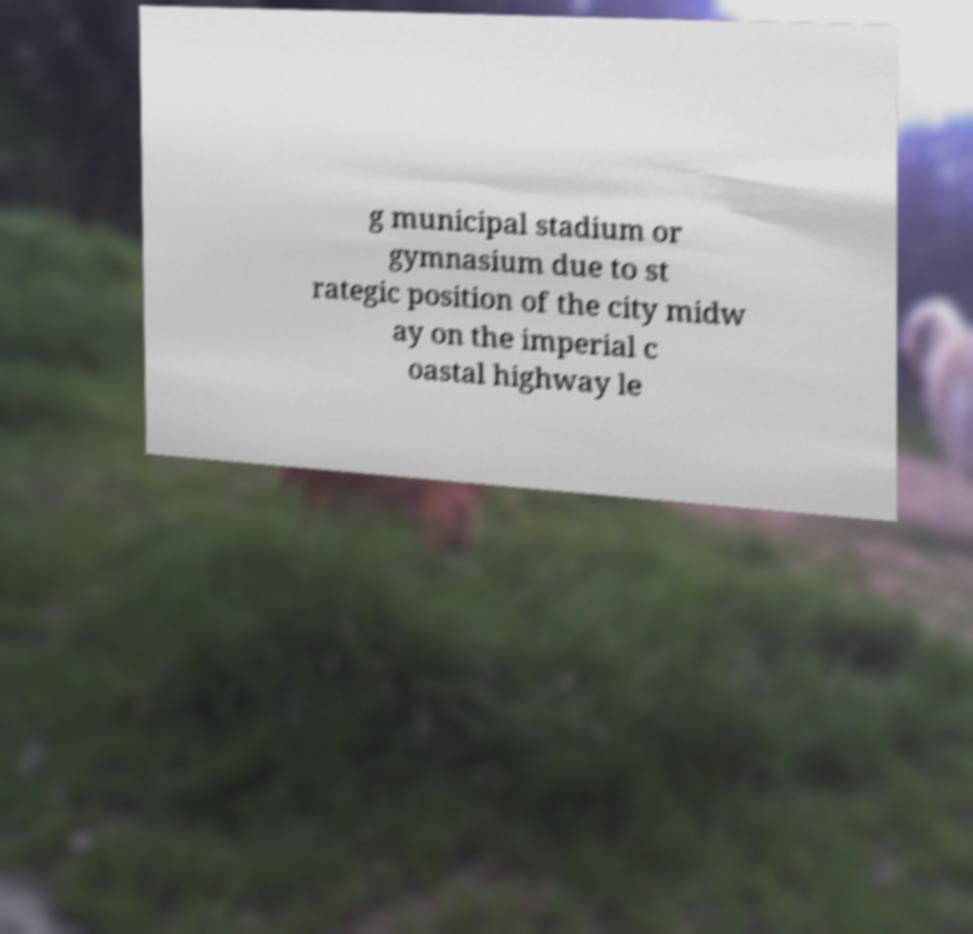There's text embedded in this image that I need extracted. Can you transcribe it verbatim? g municipal stadium or gymnasium due to st rategic position of the city midw ay on the imperial c oastal highway le 